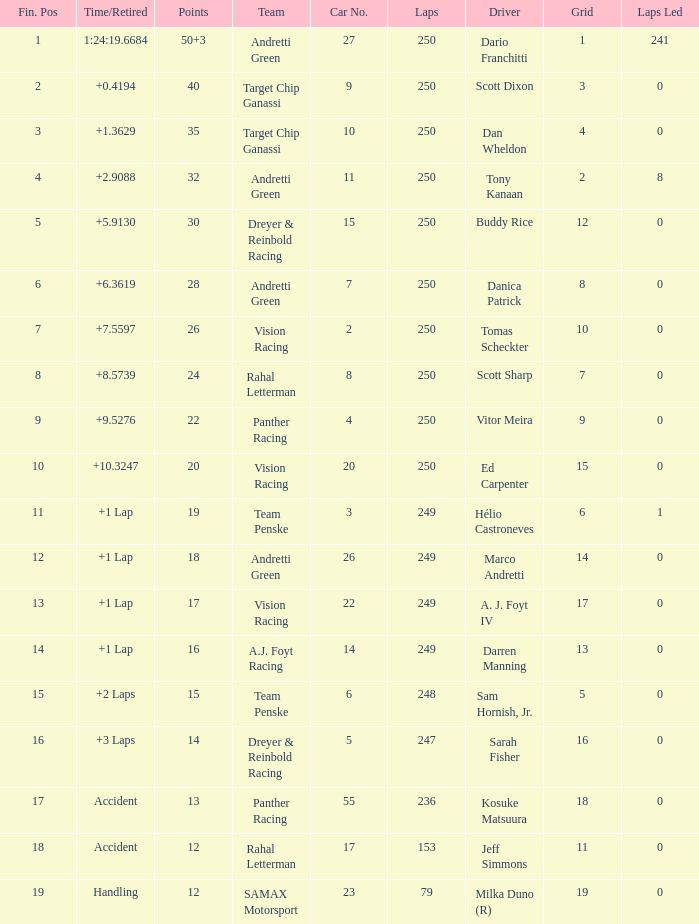Name the number of driver for fin pos of 19 1.0. 